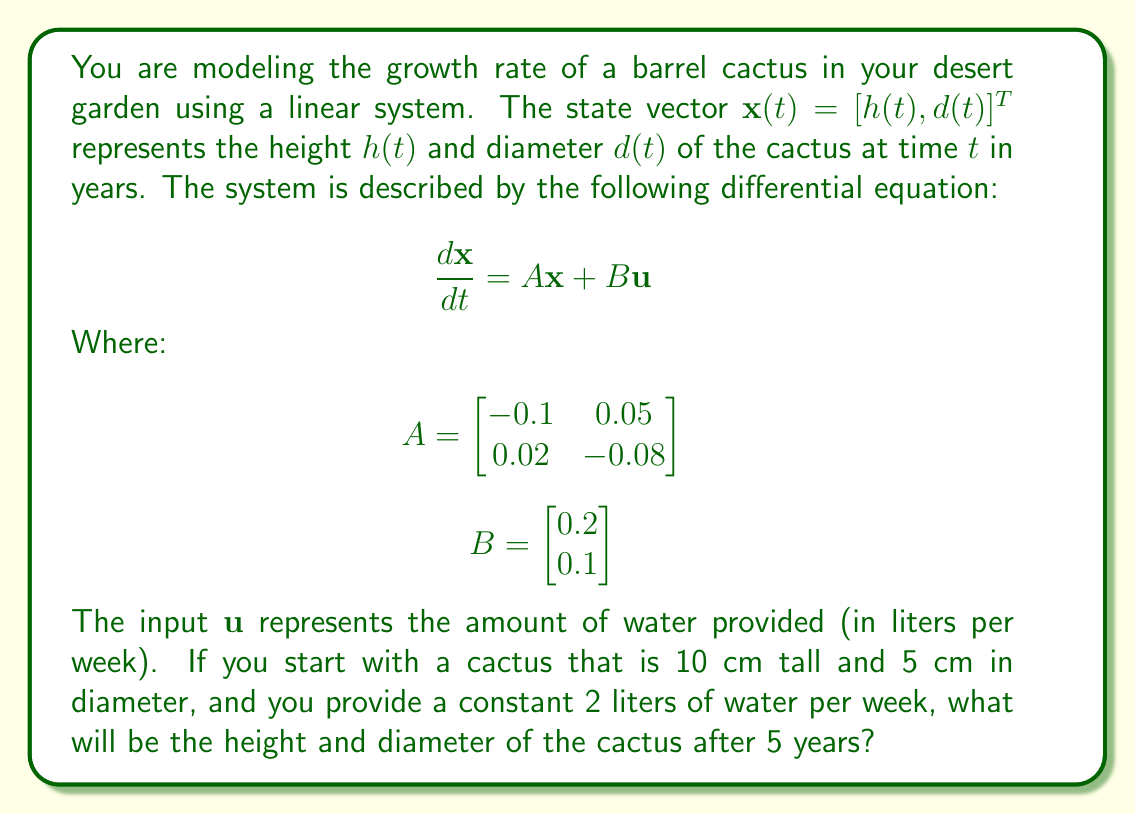Provide a solution to this math problem. To solve this problem, we need to follow these steps:

1) First, we need to find the steady-state solution. In steady-state, $\frac{d\mathbf{x}}{dt} = 0$, so:

   $$A\mathbf{x} + B\mathbf{u} = 0$$
   $$\mathbf{x} = -A^{-1}B\mathbf{u}$$

2) Calculate $A^{-1}$:
   
   $$A^{-1} = \frac{1}{(-0.1)(-0.08) - (0.05)(0.02)} \begin{bmatrix} -0.08 & -0.05 \\ -0.02 & -0.1 \end{bmatrix} = \begin{bmatrix} 10 & 6.25 \\ 2.5 & 12.5 \end{bmatrix}$$

3) Calculate the steady-state solution:

   $$\mathbf{x}_{\text{ss}} = -\begin{bmatrix} 10 & 6.25 \\ 2.5 & 12.5 \end{bmatrix} \begin{bmatrix} 0.2 \\ 0.1 \end{bmatrix} 2 = \begin{bmatrix} 45 \\ 30 \end{bmatrix}$$

4) The solution to the differential equation is of the form:

   $$\mathbf{x}(t) = \mathbf{x}_{\text{ss}} + e^{At}(\mathbf{x}(0) - \mathbf{x}_{\text{ss}})$$

   Where $\mathbf{x}(0) = [10, 5]^T$ is the initial condition.

5) We need to calculate $e^{At}$. The eigenvalues of $A$ are $\lambda_1 = -0.15$ and $\lambda_2 = -0.03$. The corresponding eigenvectors are:

   $$\mathbf{v}_1 = \begin{bmatrix} 1 \\ 0.4 \end{bmatrix}, \mathbf{v}_2 = \begin{bmatrix} 1 \\ 2 \end{bmatrix}$$

   Therefore, $e^{At} = \mathbf{V}e^{\Lambda t}\mathbf{V}^{-1}$, where:

   $$\mathbf{V} = \begin{bmatrix} 1 & 1 \\ 0.4 & 2 \end{bmatrix}, \Lambda = \begin{bmatrix} -0.15 & 0 \\ 0 & -0.03 \end{bmatrix}$$

6) Calculating $e^{At}$ for $t = 5$:

   $$e^{A5} = \begin{bmatrix} 0.5320 & 0.2936 \\ 0.1174 & 0.8699 \end{bmatrix}$$

7) Now we can calculate $\mathbf{x}(5)$:

   $$\mathbf{x}(5) = \begin{bmatrix} 45 \\ 30 \end{bmatrix} + \begin{bmatrix} 0.5320 & 0.2936 \\ 0.1174 & 0.8699 \end{bmatrix} \begin{bmatrix} -35 \\ -25 \end{bmatrix} = \begin{bmatrix} 27.38 \\ 17.95 \end{bmatrix}$$

Therefore, after 5 years, the cactus will be approximately 27.38 cm tall and 17.95 cm in diameter.
Answer: After 5 years, the cactus will be approximately 27.38 cm tall and 17.95 cm in diameter. 